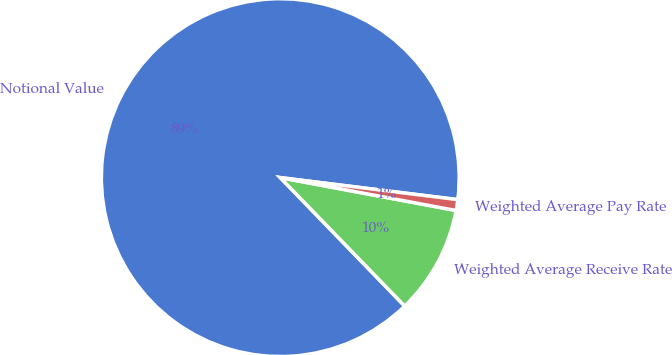Convert chart to OTSL. <chart><loc_0><loc_0><loc_500><loc_500><pie_chart><fcel>Notional Value<fcel>Weighted Average Receive Rate<fcel>Weighted Average Pay Rate<nl><fcel>89.21%<fcel>9.81%<fcel>0.98%<nl></chart> 